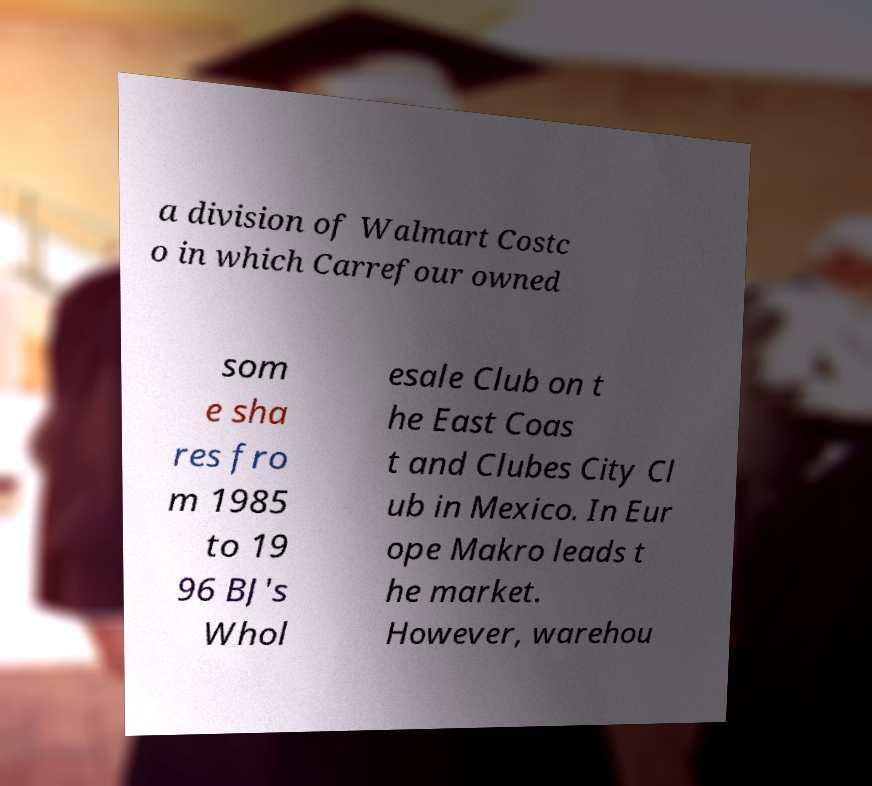Could you assist in decoding the text presented in this image and type it out clearly? a division of Walmart Costc o in which Carrefour owned som e sha res fro m 1985 to 19 96 BJ's Whol esale Club on t he East Coas t and Clubes City Cl ub in Mexico. In Eur ope Makro leads t he market. However, warehou 